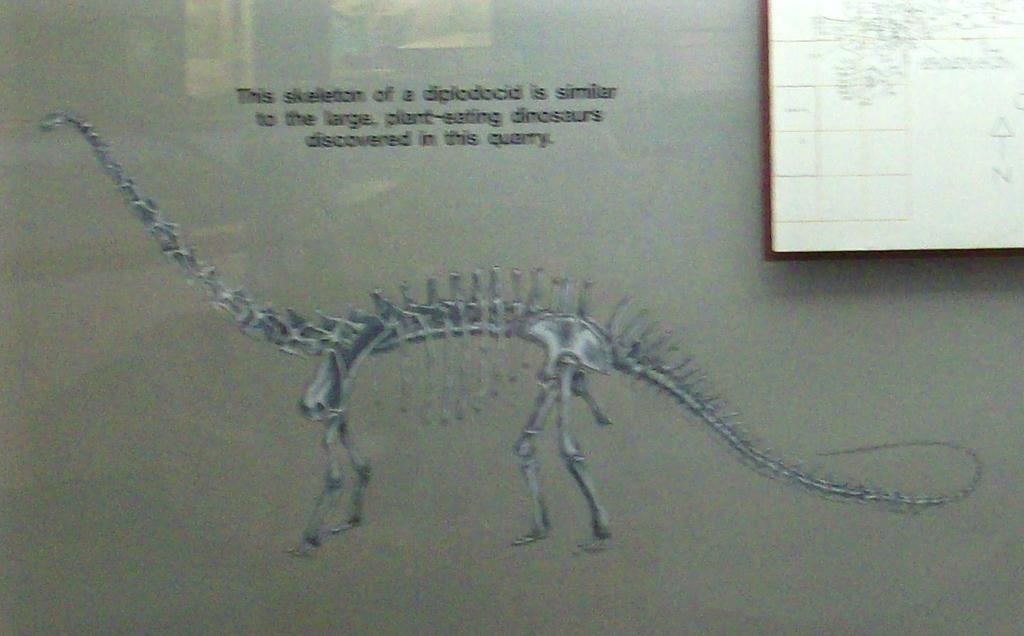<image>
Summarize the visual content of the image. A picture of a skeleton of a dinosaur is shown at a quarry. 